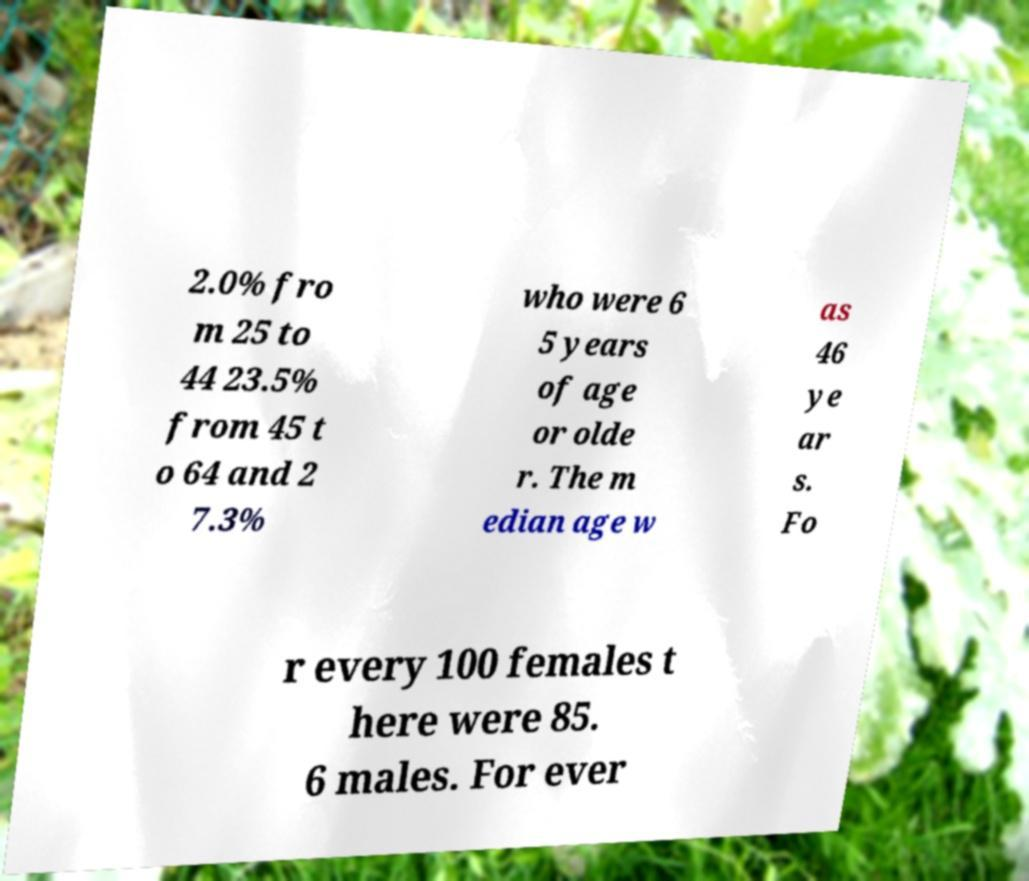What messages or text are displayed in this image? I need them in a readable, typed format. 2.0% fro m 25 to 44 23.5% from 45 t o 64 and 2 7.3% who were 6 5 years of age or olde r. The m edian age w as 46 ye ar s. Fo r every 100 females t here were 85. 6 males. For ever 